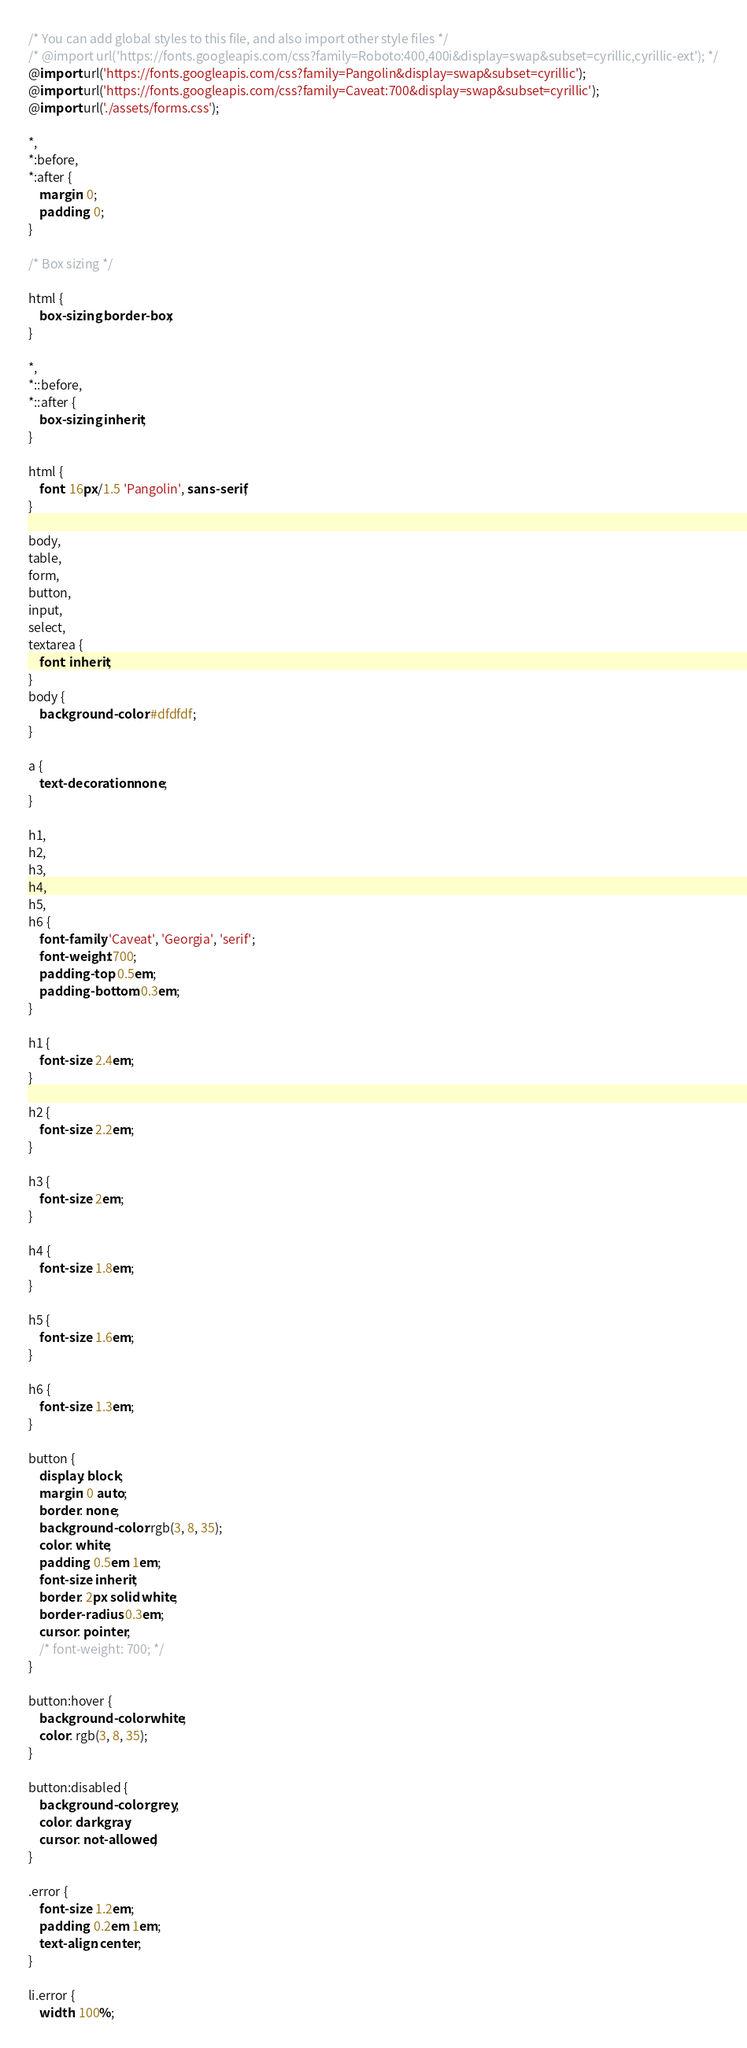<code> <loc_0><loc_0><loc_500><loc_500><_CSS_>/* You can add global styles to this file, and also import other style files */
/* @import url('https://fonts.googleapis.com/css?family=Roboto:400,400i&display=swap&subset=cyrillic,cyrillic-ext'); */
@import url('https://fonts.googleapis.com/css?family=Pangolin&display=swap&subset=cyrillic');
@import url('https://fonts.googleapis.com/css?family=Caveat:700&display=swap&subset=cyrillic');
@import url('./assets/forms.css');

*,
*:before,
*:after {
	margin: 0;
	padding: 0;
}

/* Box sizing */

html {
	box-sizing: border-box;
}

*,
*::before,
*::after {
	box-sizing: inherit;
}

html {
	font: 16px/1.5 'Pangolin', sans-serif;
}

body,
table,
form,
button,
input,
select,
textarea {
	font: inherit;
}
body {
	background-color: #dfdfdf;
}

a {
	text-decoration: none;
}

h1,
h2,
h3,
h4,
h5,
h6 {
	font-family: 'Caveat', 'Georgia', 'serif';
	font-weight: 700;
	padding-top: 0.5em;
	padding-bottom: 0.3em;
}

h1 {
	font-size: 2.4em;
}

h2 {
	font-size: 2.2em;
}

h3 {
	font-size: 2em;
}

h4 {
	font-size: 1.8em;
}

h5 {
	font-size: 1.6em;
}

h6 {
	font-size: 1.3em;
}

button {
	display: block;
	margin: 0 auto;
	border: none;
	background-color: rgb(3, 8, 35);
	color: white;
	padding: 0.5em 1em;
	font-size: inherit;
	border: 2px solid white;
	border-radius: 0.3em;
	cursor: pointer;
	/* font-weight: 700; */
}

button:hover {
	background-color: white;
	color: rgb(3, 8, 35);
}

button:disabled {
	background-color: grey;
	color: darkgray;
	cursor: not-allowed;
}

.error {
	font-size: 1.2em;
	padding: 0.2em 1em;
	text-align: center;
}

li.error {
	width: 100%;</code> 